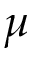<formula> <loc_0><loc_0><loc_500><loc_500>\mu</formula> 